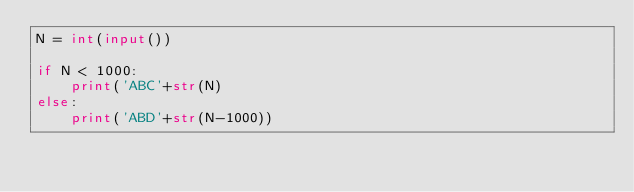<code> <loc_0><loc_0><loc_500><loc_500><_Python_>N = int(input())

if N < 1000:
    print('ABC'+str(N)
else:
    print('ABD'+str(N-1000))</code> 